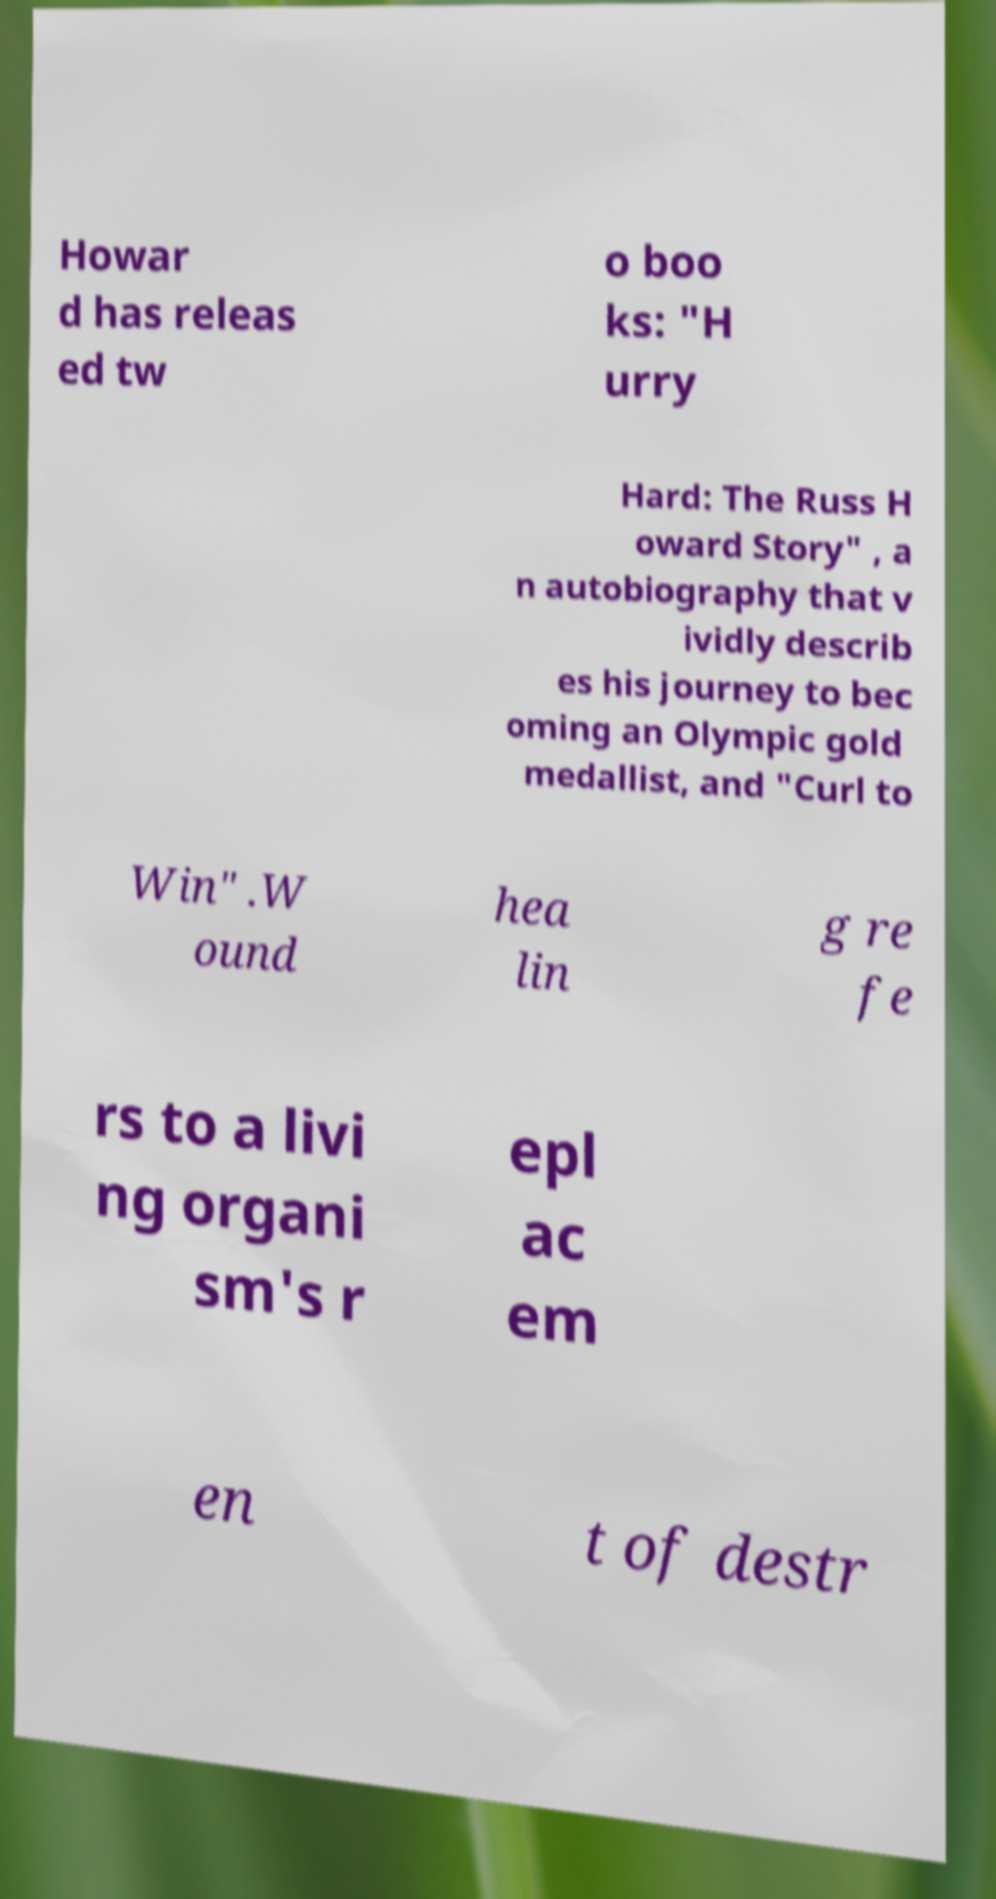There's text embedded in this image that I need extracted. Can you transcribe it verbatim? Howar d has releas ed tw o boo ks: "H urry Hard: The Russ H oward Story" , a n autobiography that v ividly describ es his journey to bec oming an Olympic gold medallist, and "Curl to Win" .W ound hea lin g re fe rs to a livi ng organi sm's r epl ac em en t of destr 